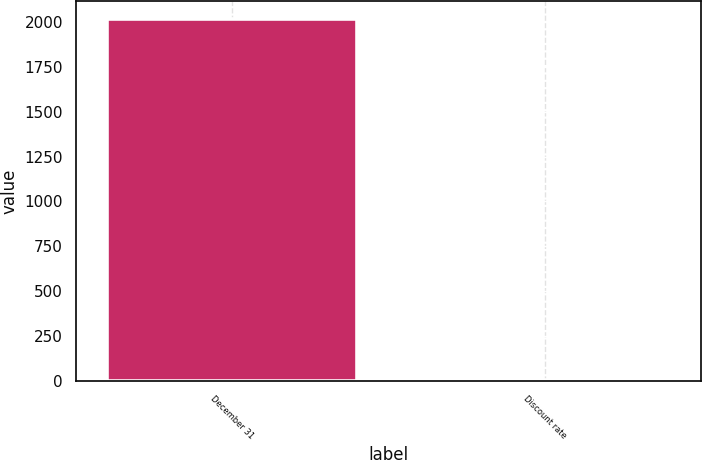Convert chart. <chart><loc_0><loc_0><loc_500><loc_500><bar_chart><fcel>December 31<fcel>Discount rate<nl><fcel>2017<fcel>3.5<nl></chart> 